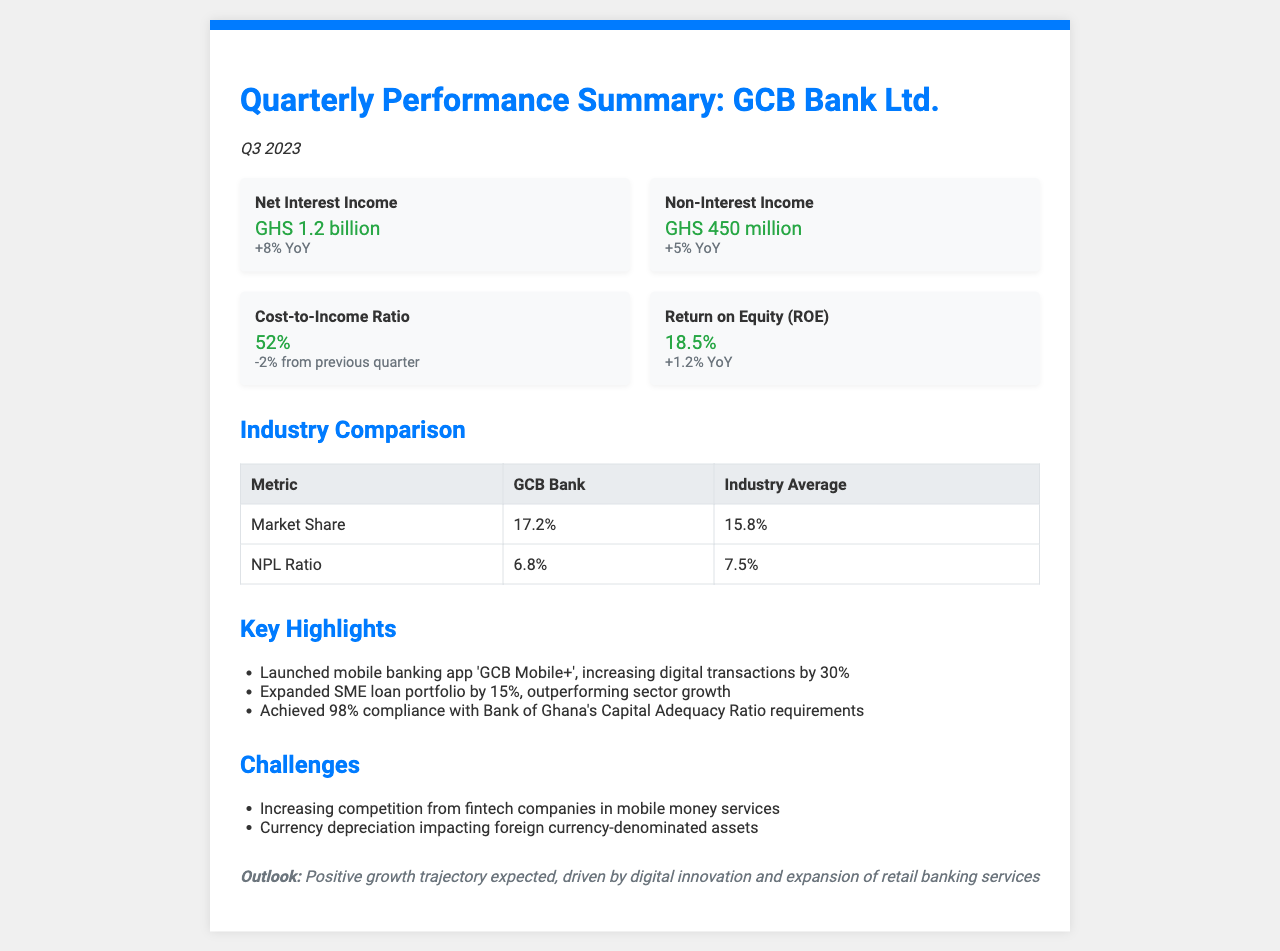What is the net interest income? The net interest income is explicitly stated in the document as GHS 1.2 billion.
Answer: GHS 1.2 billion What is the cost-to-income ratio? The document provides the cost-to-income ratio as 52%.
Answer: 52% What is GCB Bank's market share? The market share for GCB Bank, according to the industry comparison in the document, is 17.2%.
Answer: 17.2% What significant increase is mentioned regarding the mobile banking app? The document states that the launch of the mobile banking app 'GCB Mobile+' increased digital transactions by 30%.
Answer: 30% What is the non-performing loan (NPL) ratio for GCB Bank? The document indicates the non-performing loan (NPL) ratio for GCB Bank as 6.8%.
Answer: 6.8% Which metric improved by 1.2% year over year? The document mentions that Return on Equity (ROE) improved by 1.2% year over year.
Answer: Return on Equity (ROE) What challenge is highlighted regarding competition? The document identifies increasing competition from fintech companies in mobile money services as a challenge.
Answer: Fintech competition What is the outlook for GCB Bank as described in the document? The outlook for GCB Bank is described as a positive growth trajectory expected, driven by digital innovation and expansion of retail banking services.
Answer: Positive growth trajectory What amount did non-interest income reach? The non-interest income is stated in the document as GHS 450 million.
Answer: GHS 450 million 